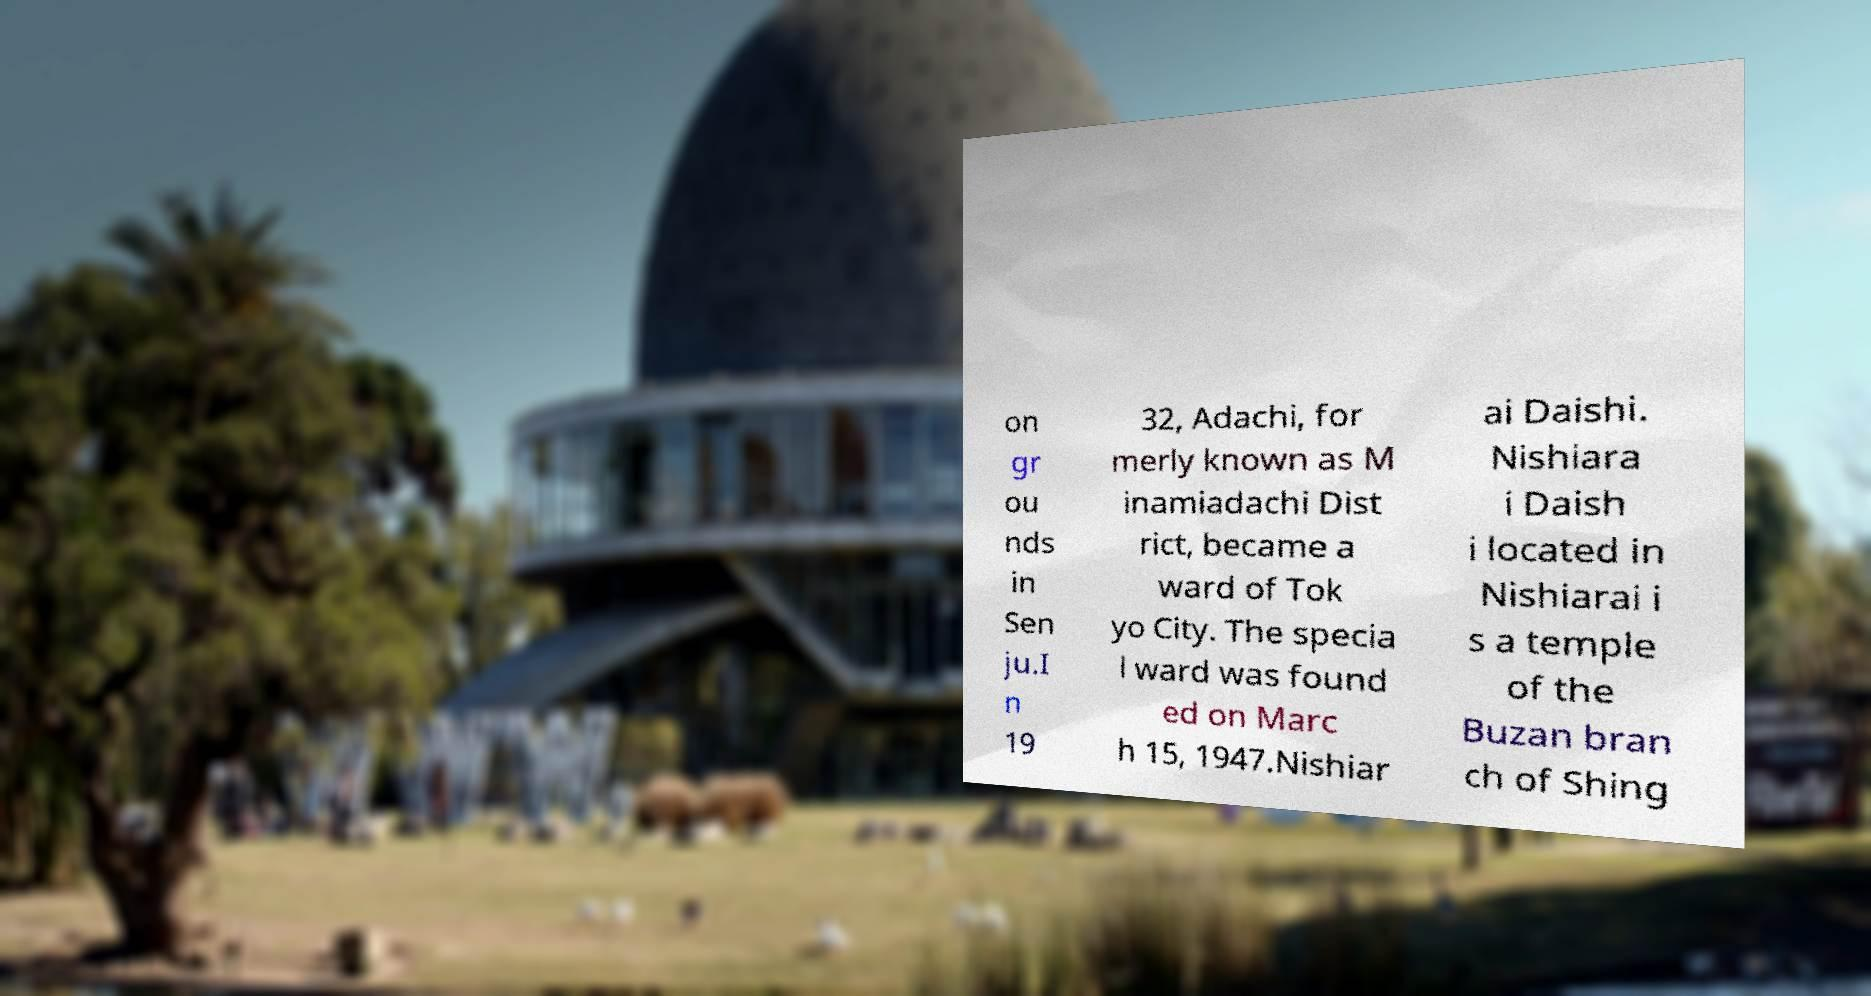Can you accurately transcribe the text from the provided image for me? on gr ou nds in Sen ju.I n 19 32, Adachi, for merly known as M inamiadachi Dist rict, became a ward of Tok yo City. The specia l ward was found ed on Marc h 15, 1947.Nishiar ai Daishi. Nishiara i Daish i located in Nishiarai i s a temple of the Buzan bran ch of Shing 